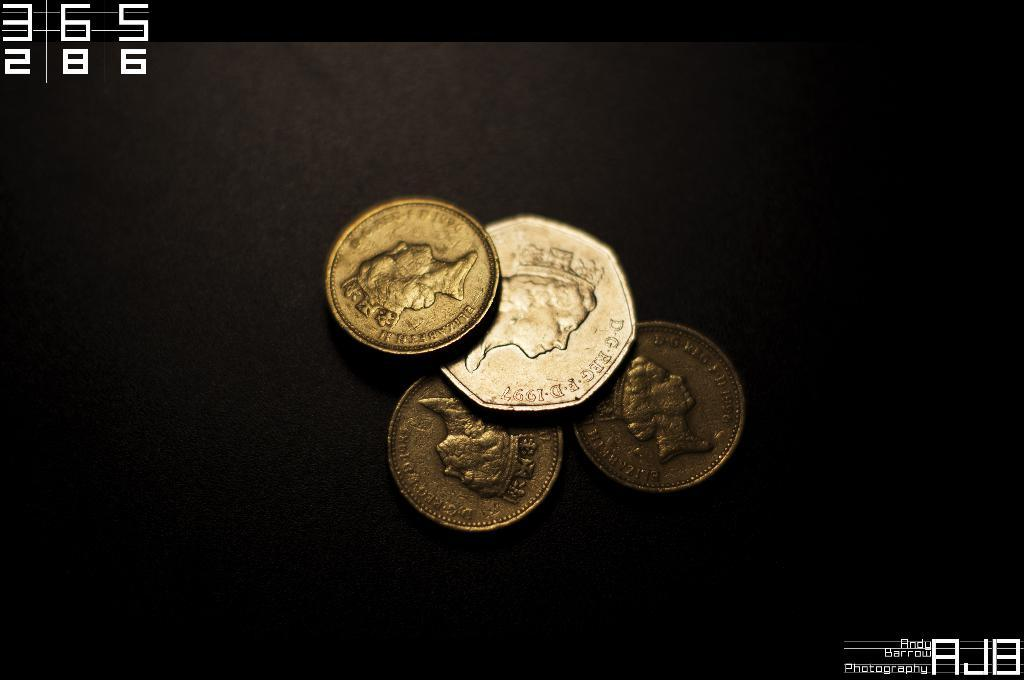<image>
Summarize the visual content of the image. Golden coins that say "Elizabeth" on it and has her picture on it as well. 